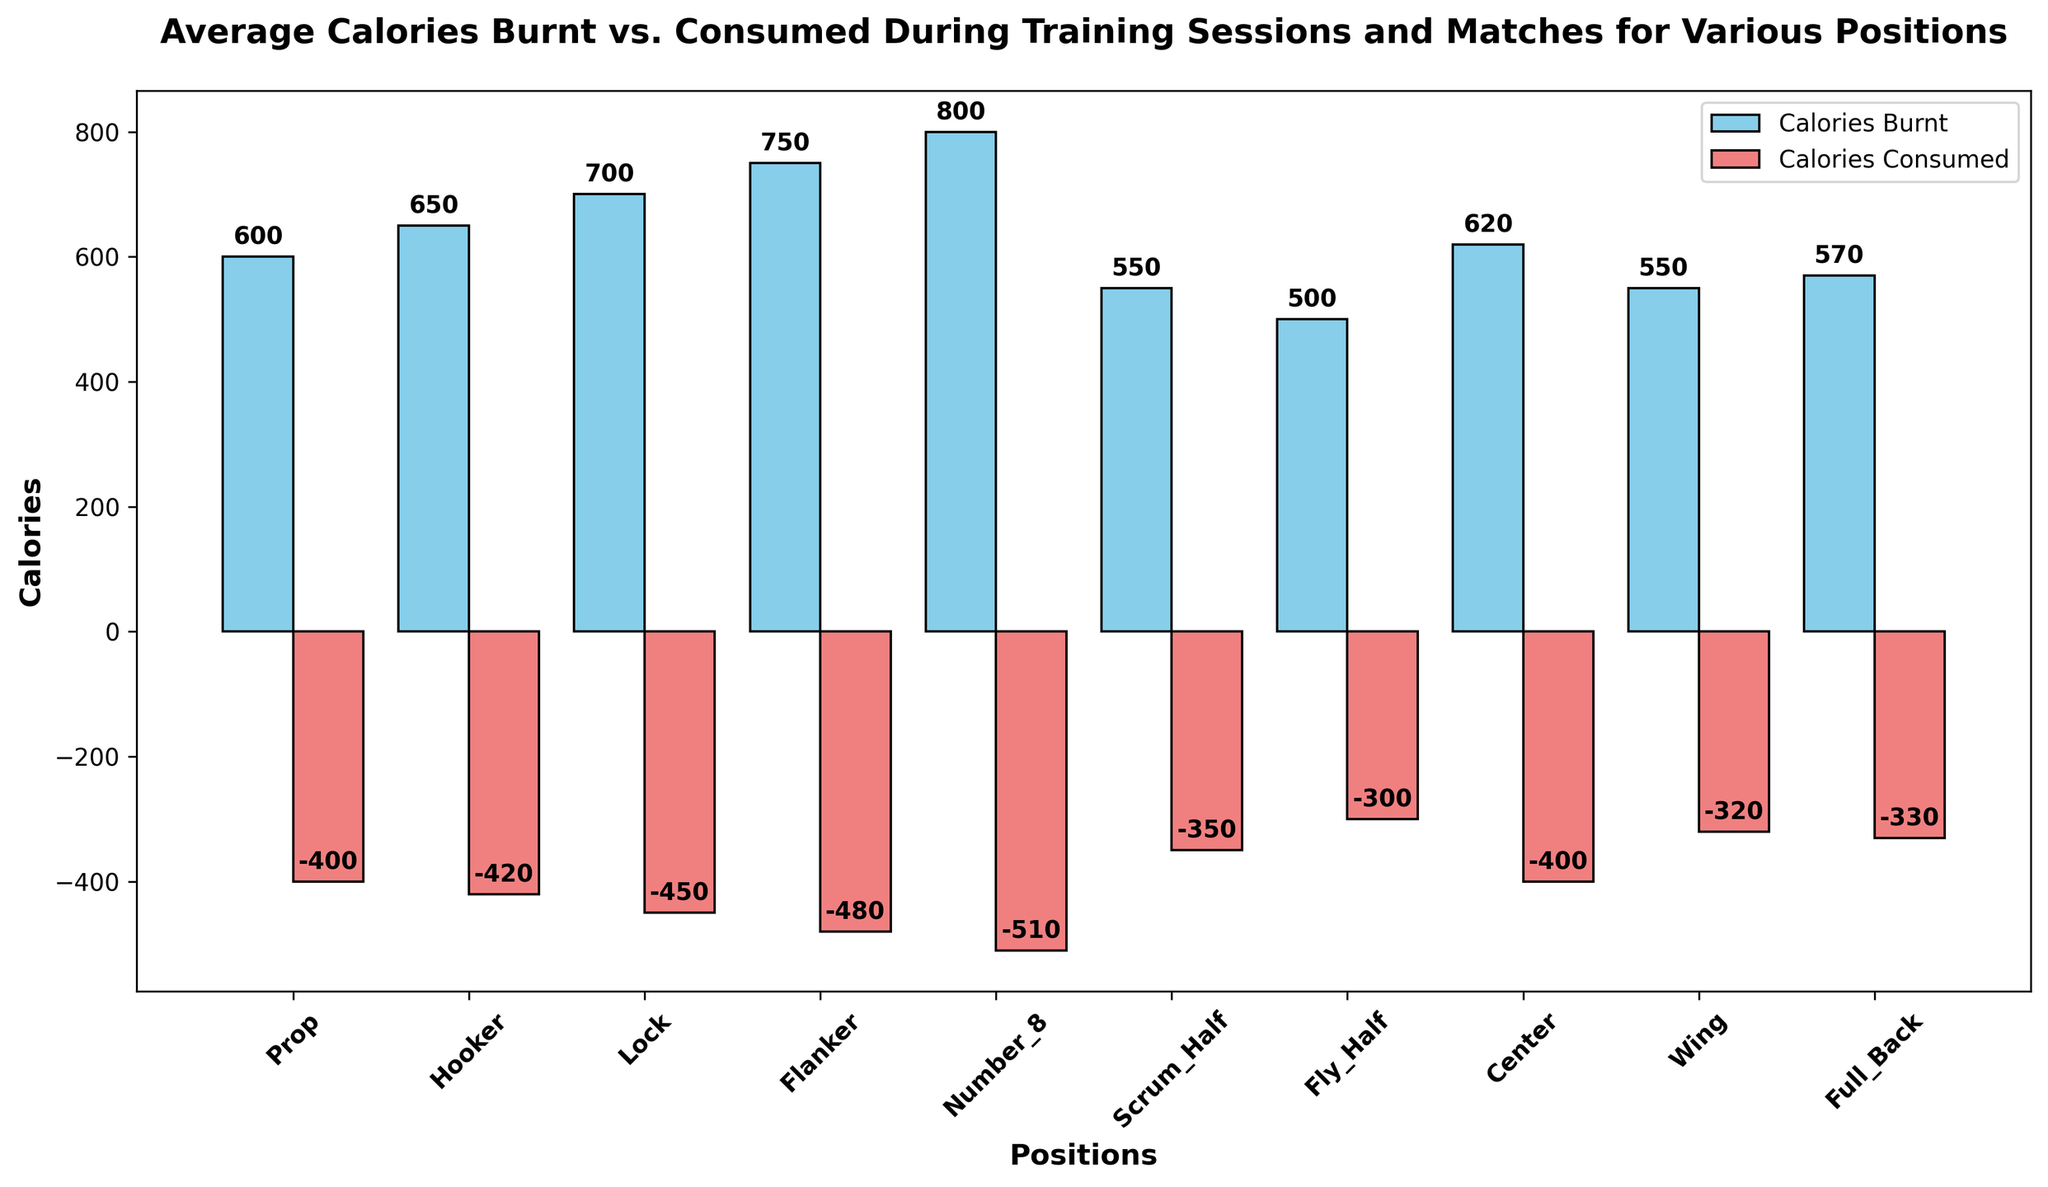What's the highest number of calories burnt by any position? The highest value for the Calories Burnt is 800. This corresponds to the Number_8 position, which is visually the tallest bar among the burnt calories.
Answer: 800 How many more calories are burnt by Full_Back compared to Wing? Full_Back burns 570 calories, and Wing burns 550 calories. The difference is 570 - 550 = 20.
Answer: 20 Which position consumed the least calories? The position that consumed the least calories is Fly_Half, as indicated by the smallest negative bar for calories consumed at -300.
Answer: Fly_Half What is the average number of calories burnt by Scrum_Half and Fly_Half? Sum the calories burnt by Scrum_Half (550) and Fly_Half (500), which equals 1050. Then divide by 2 to get the average: 1050 / 2 = 525.
Answer: 525 Are there any positions where the difference between calories burnt and consumed is the same? By calculating the difference for each position, we note that Prop and Center both have a difference of 200 (600-400 for Prop and 620-400 for Center).
Answer: Yes Which position had the largest absolute difference between calories burnt and consumed? The difference is the highest for Number_8: 800 - 510 = 290.
Answer: Number_8 Do most positions have burnt calories greater than consumed? Visually comparing the heights of the blue bars (calories burnt) to the negative red bars (calories consumed), it is apparent that for all positions, burnt calories are greater.
Answer: Yes Is there any position where the calories burnt is twice as much as the calories consumed? For Number_8, burnt (800) is more than twice consumed (510). For other positions, none have such a relationship.
Answer: No What is the total number of calories burnt by the three forward positions (Prop, Hooker, Lock)? Sum the burnt calories for Prop, Hooker, and Lock: 600 + 650 + 700 = 1950.
Answer: 1950 Is the range of calories burnt broader than calories consumed? The range for calories burnt (maximum 800 to minimum 500) is 300. For calories consumed (minimum -510 to maximum -300), the range is 210. Therefore, the range is broader for calories burnt.
Answer: Yes 